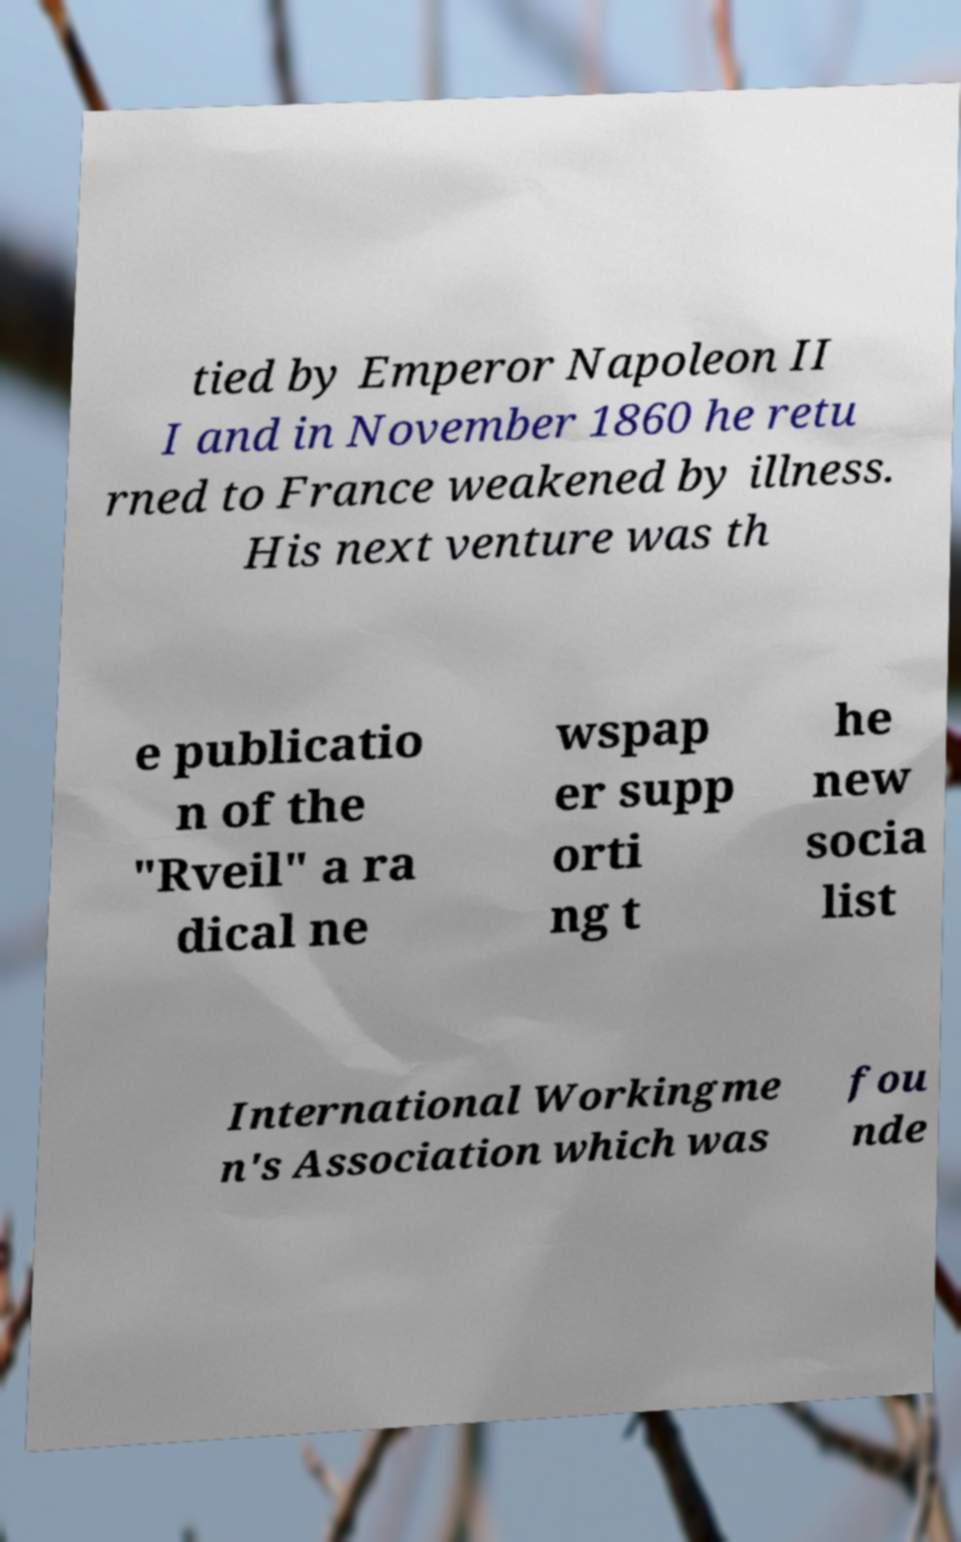Please read and relay the text visible in this image. What does it say? tied by Emperor Napoleon II I and in November 1860 he retu rned to France weakened by illness. His next venture was th e publicatio n of the "Rveil" a ra dical ne wspap er supp orti ng t he new socia list International Workingme n's Association which was fou nde 